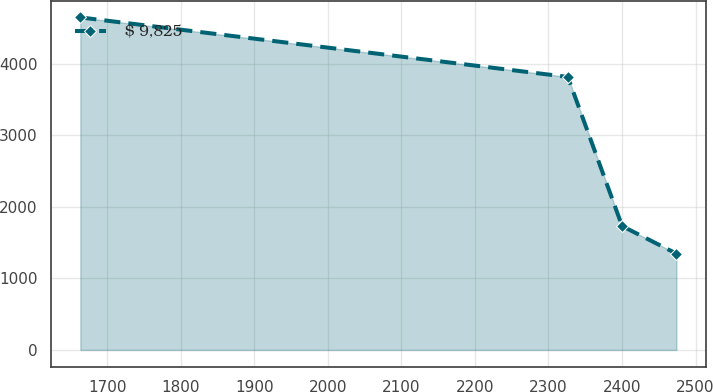<chart> <loc_0><loc_0><loc_500><loc_500><line_chart><ecel><fcel>$ 9,825<nl><fcel>1663.37<fcel>4645.13<nl><fcel>2326.33<fcel>3813.93<nl><fcel>2400.18<fcel>1730.29<nl><fcel>2474.03<fcel>1345.49<nl></chart> 